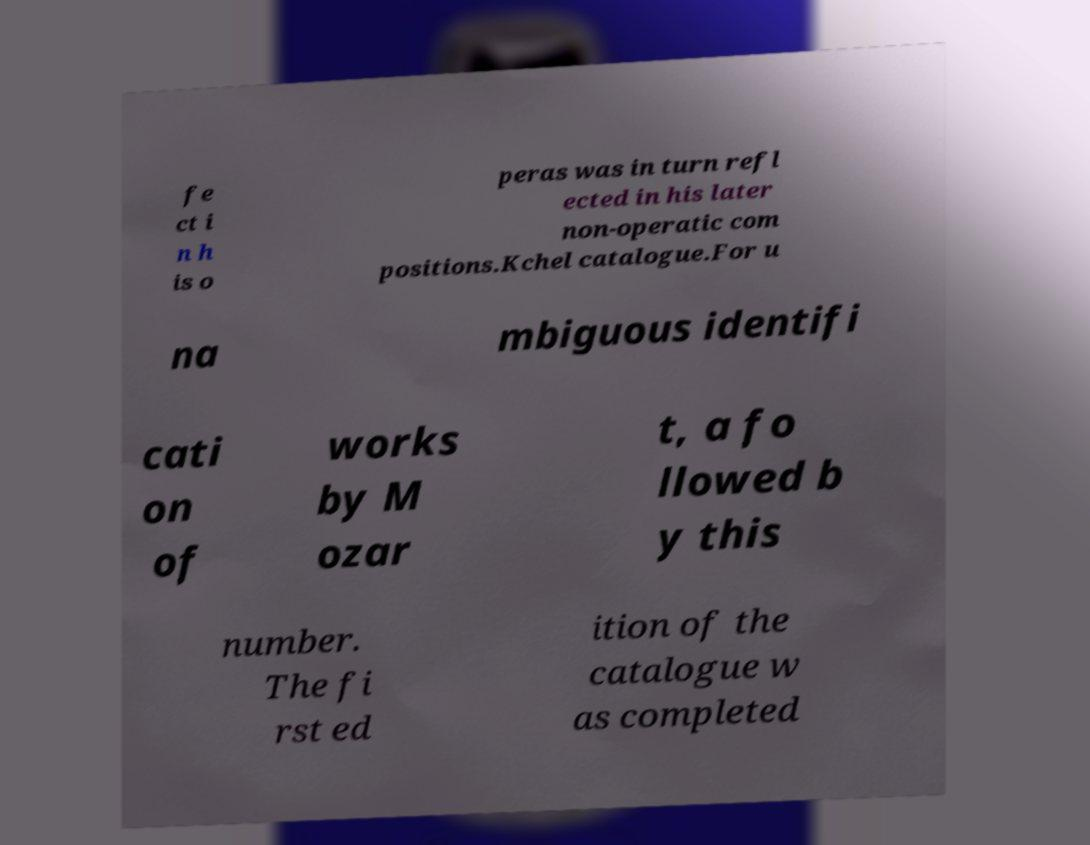Please read and relay the text visible in this image. What does it say? fe ct i n h is o peras was in turn refl ected in his later non-operatic com positions.Kchel catalogue.For u na mbiguous identifi cati on of works by M ozar t, a fo llowed b y this number. The fi rst ed ition of the catalogue w as completed 